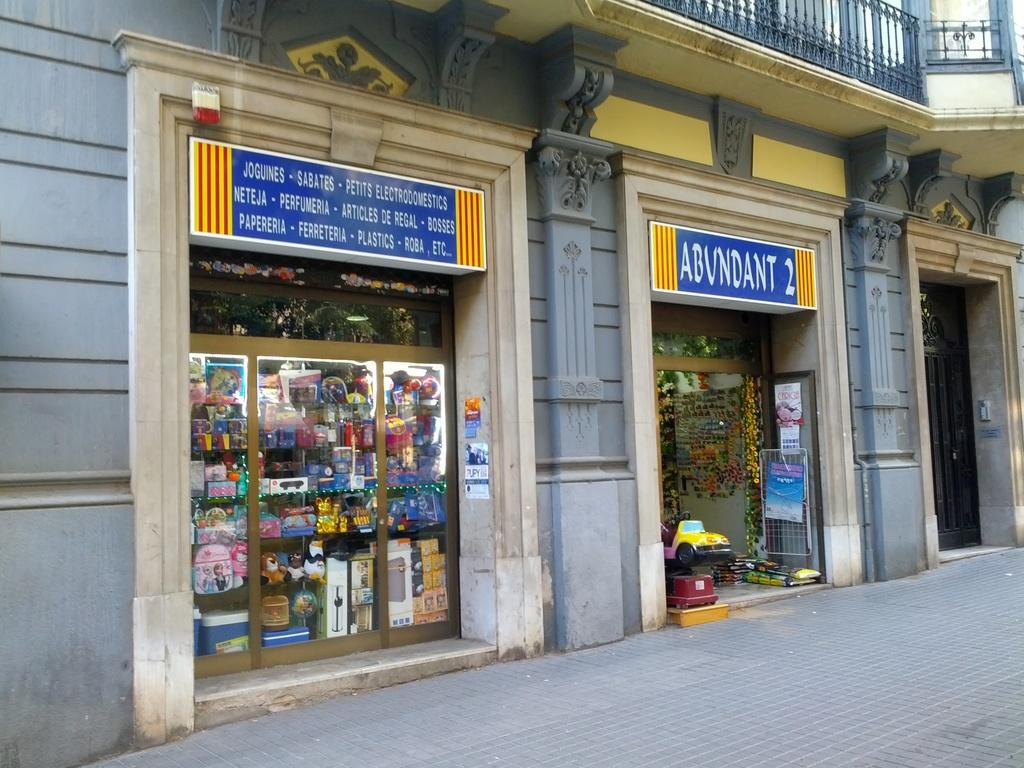<image>
Summarize the visual content of the image. a storefront for Abundant 2 has different things for sale 